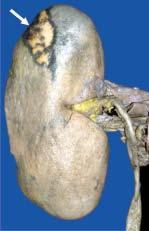s the margin pale while the margin is haemorrhagic?
Answer the question using a single word or phrase. No 